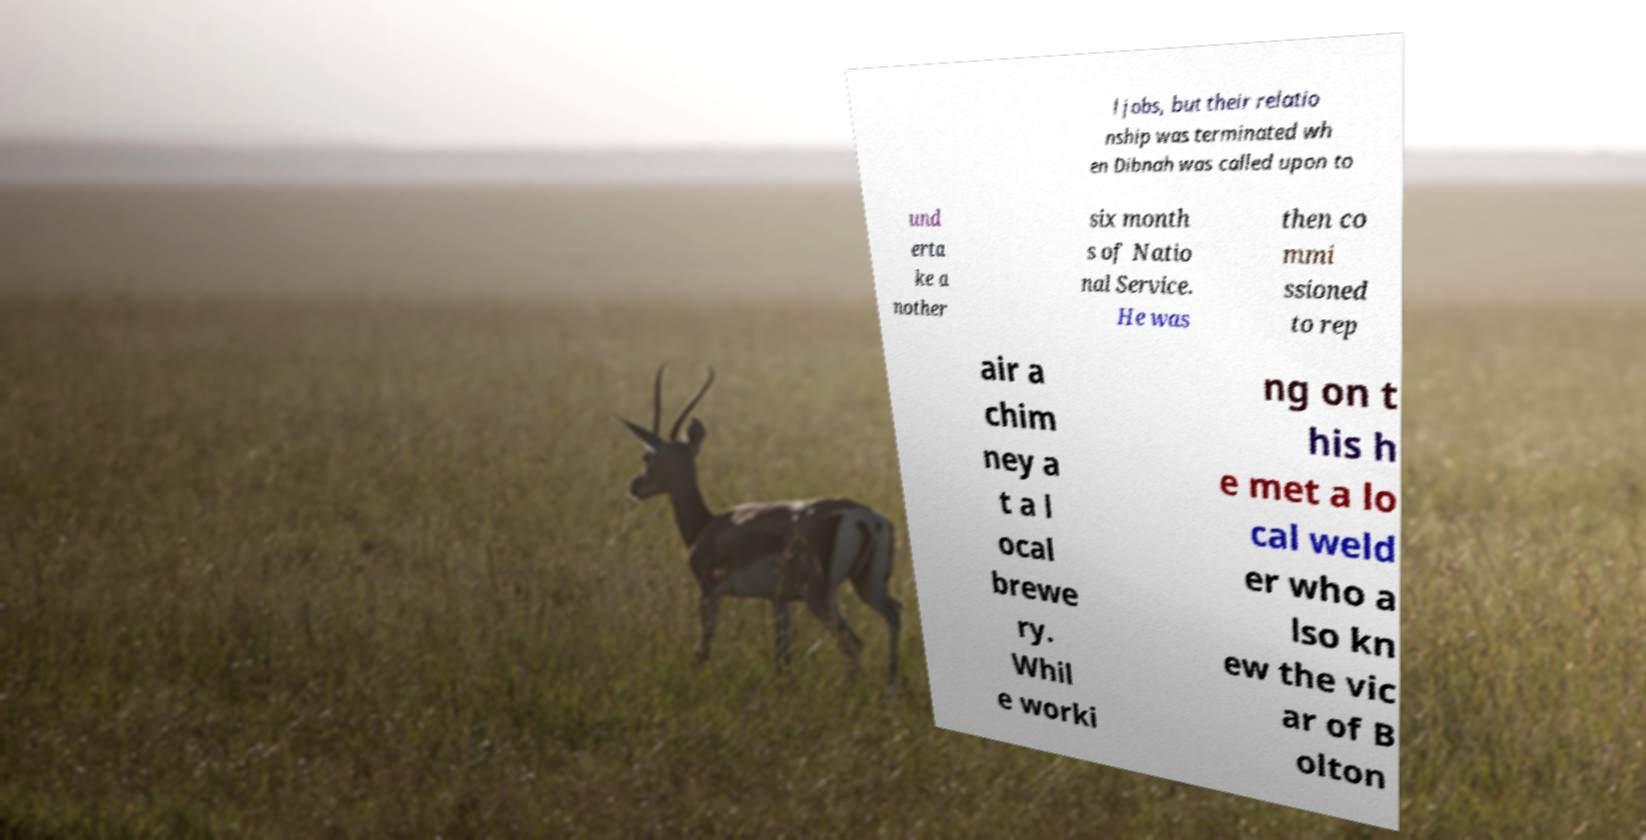Can you read and provide the text displayed in the image?This photo seems to have some interesting text. Can you extract and type it out for me? l jobs, but their relatio nship was terminated wh en Dibnah was called upon to und erta ke a nother six month s of Natio nal Service. He was then co mmi ssioned to rep air a chim ney a t a l ocal brewe ry. Whil e worki ng on t his h e met a lo cal weld er who a lso kn ew the vic ar of B olton 